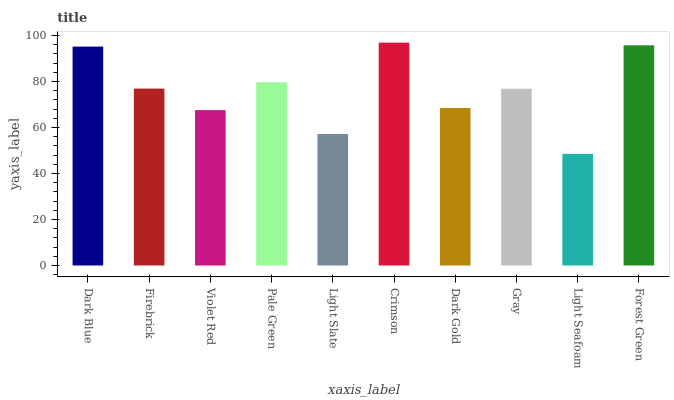Is Light Seafoam the minimum?
Answer yes or no. Yes. Is Crimson the maximum?
Answer yes or no. Yes. Is Firebrick the minimum?
Answer yes or no. No. Is Firebrick the maximum?
Answer yes or no. No. Is Dark Blue greater than Firebrick?
Answer yes or no. Yes. Is Firebrick less than Dark Blue?
Answer yes or no. Yes. Is Firebrick greater than Dark Blue?
Answer yes or no. No. Is Dark Blue less than Firebrick?
Answer yes or no. No. Is Firebrick the high median?
Answer yes or no. Yes. Is Gray the low median?
Answer yes or no. Yes. Is Pale Green the high median?
Answer yes or no. No. Is Firebrick the low median?
Answer yes or no. No. 